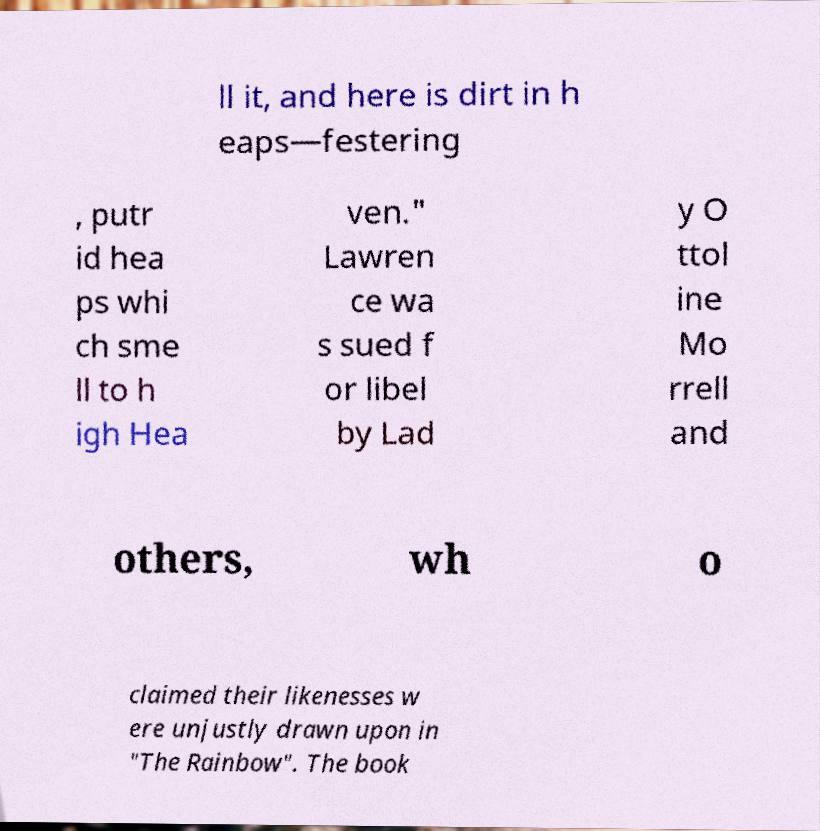What messages or text are displayed in this image? I need them in a readable, typed format. ll it, and here is dirt in h eaps—festering , putr id hea ps whi ch sme ll to h igh Hea ven." Lawren ce wa s sued f or libel by Lad y O ttol ine Mo rrell and others, wh o claimed their likenesses w ere unjustly drawn upon in "The Rainbow". The book 